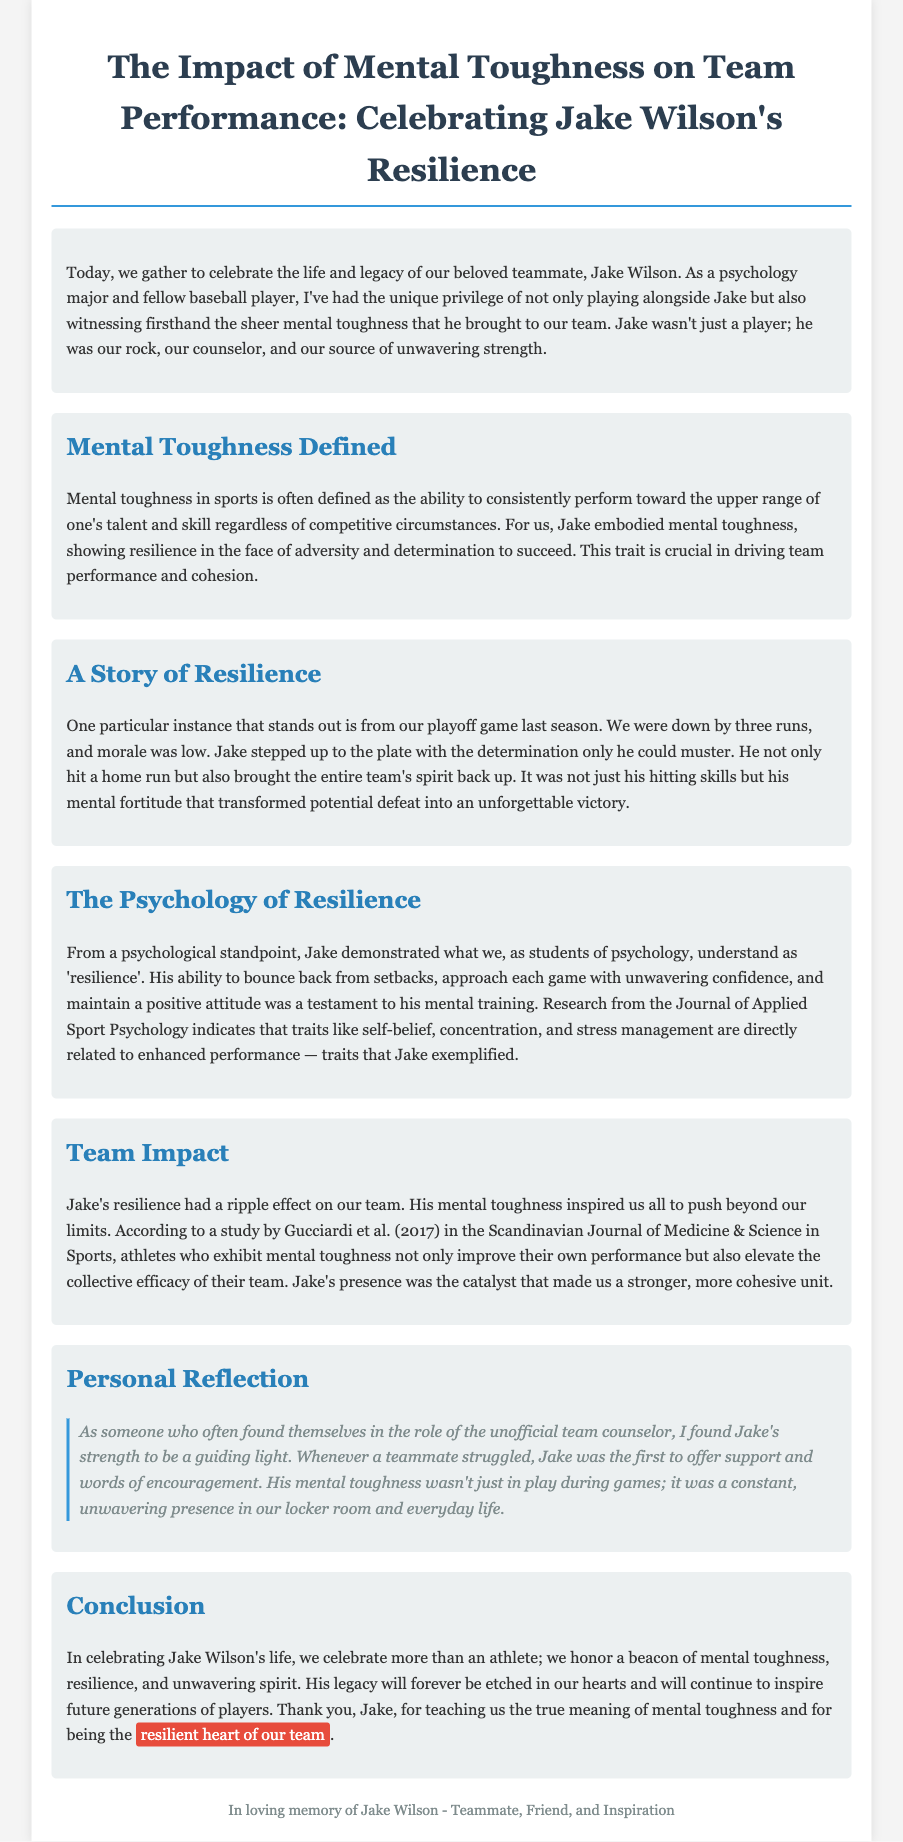What was Jake Wilson's major? The document states that the speaker is a psychology major, which implies that Jake was likely connected to the same field, although this is not explicitly confirmed. However, the context suggests a focus on psychology.
Answer: Psychology What key event is highlighted in the eulogy? The eulogy recalls a significant playoff game where Jake's actions uplifted the team when they were down.
Answer: Playoff game What trait did Jake embody according to the eulogy? The document specifically mentions that Jake embodied mental toughness, which is a central theme in the eulogy.
Answer: Mental toughness Which publication is referenced regarding resilience? The eulogy cites research from the Journal of Applied Sport Psychology when discussing resilience-related traits.
Answer: Journal of Applied Sport Psychology What effect did Jake's resilience have on the team? The document discusses how Jake's resilience inspired the entire team to push beyond their limits, suggesting a positive impact on team morale and performance.
Answer: Ripple effect What color is the highlight used in the conclusion? In the conclusion, a specific color is used to emphasize Jake’s role and legacy. The highlight background is noted in the styling.
Answer: Red Who was the first to offer support among teammates? According to personal reflection in the eulogy, Jake was recognized as the person who first offered support during difficult times.
Answer: Jake What is the concluding sentiment expressed in the eulogy? The document concludes with a gratitude expression towards Jake for teaching the team about mental toughness and being the resilient heart of the team.
Answer: Thank you, Jake 